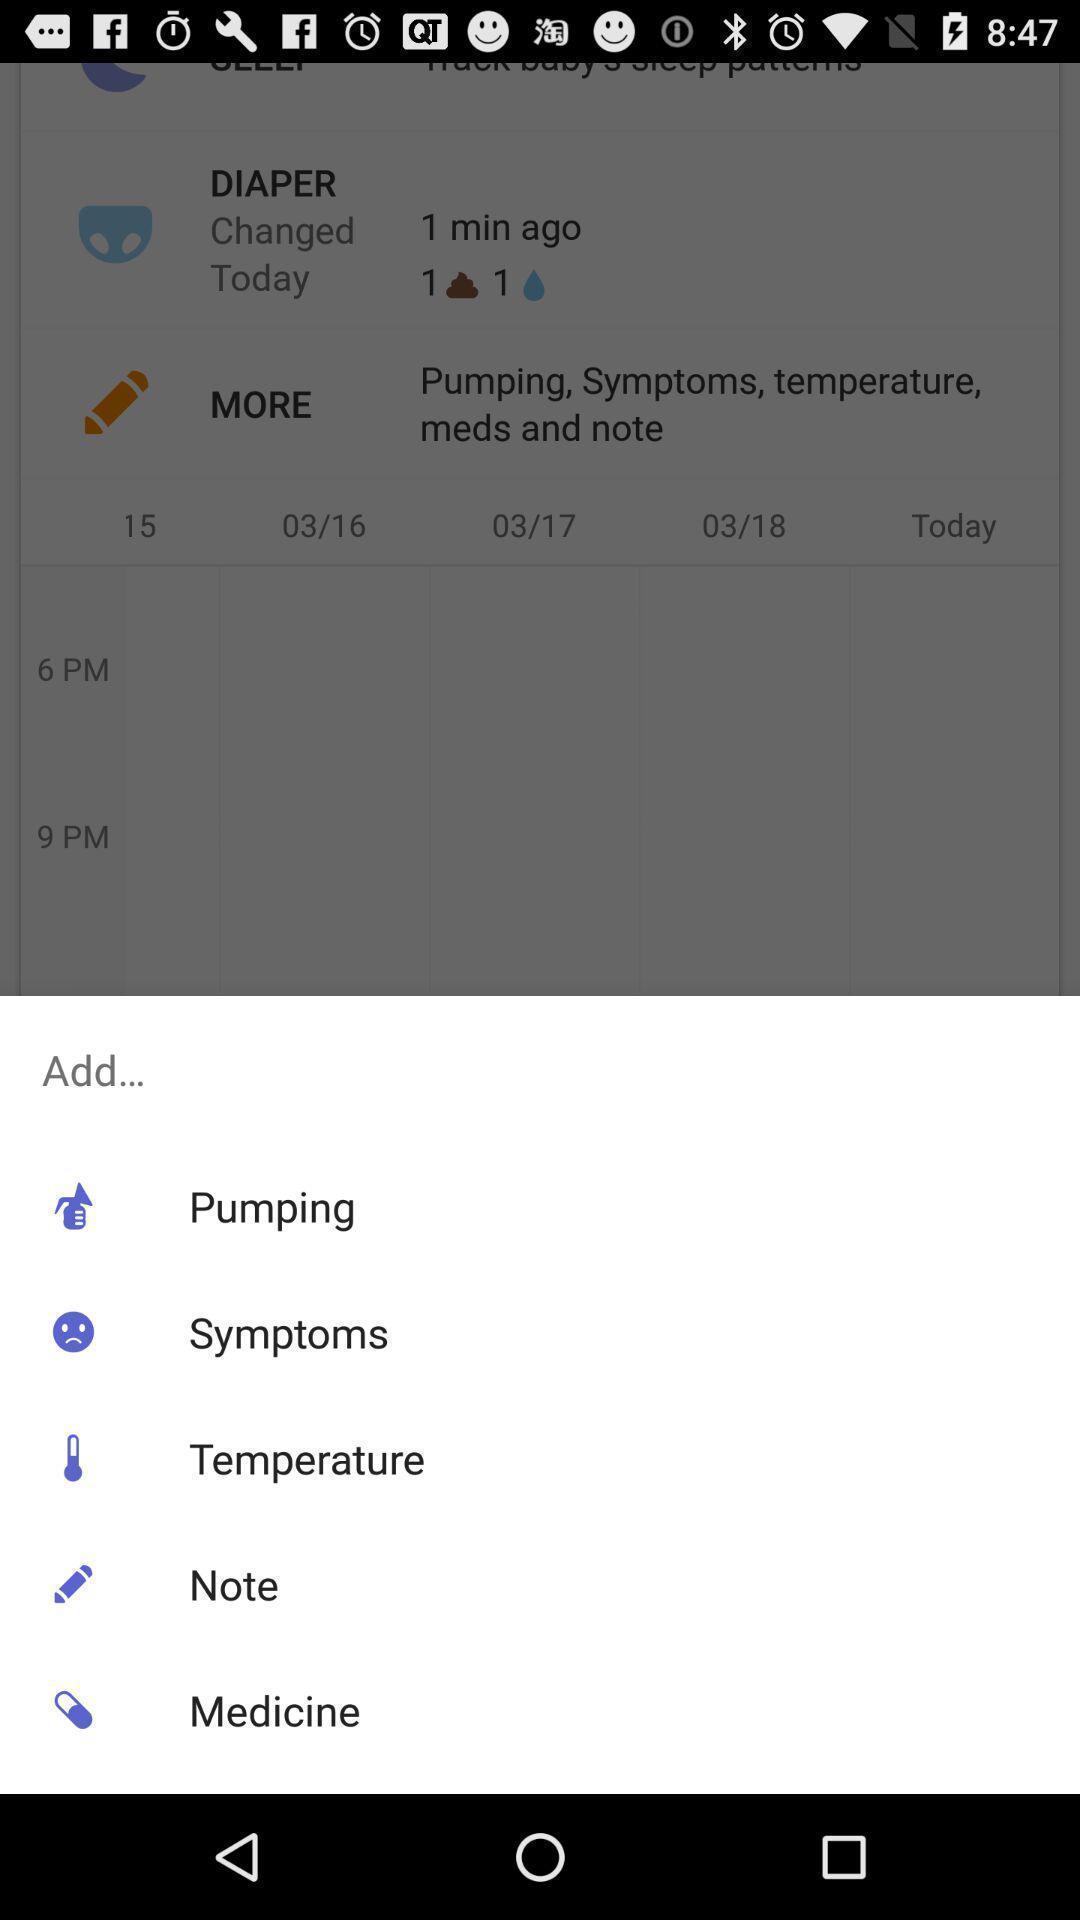Tell me about the visual elements in this screen capture. Pop-up showing different options. 